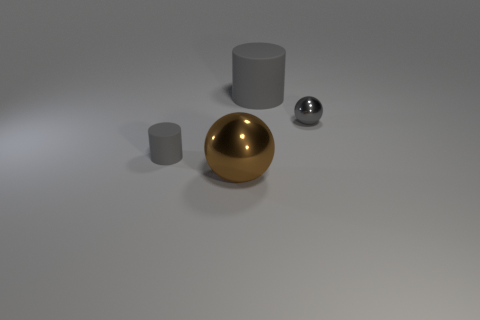Subtract 2 balls. How many balls are left? 0 Subtract all red spheres. Subtract all red cylinders. How many spheres are left? 2 Subtract all blue blocks. How many cyan cylinders are left? 0 Subtract all small gray metal blocks. Subtract all large cylinders. How many objects are left? 3 Add 2 gray cylinders. How many gray cylinders are left? 4 Add 2 small gray objects. How many small gray objects exist? 4 Add 3 cyan matte cylinders. How many objects exist? 7 Subtract all gray balls. How many balls are left? 1 Subtract 0 brown cylinders. How many objects are left? 4 